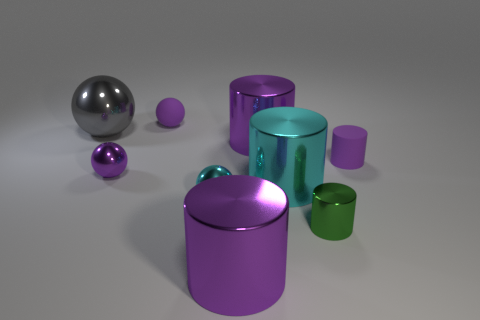Subtract all red balls. How many purple cylinders are left? 3 Subtract 1 spheres. How many spheres are left? 3 Subtract all gray cylinders. Subtract all green blocks. How many cylinders are left? 5 Add 1 matte objects. How many objects exist? 10 Subtract all cylinders. How many objects are left? 4 Add 1 metal balls. How many metal balls are left? 4 Add 2 tiny purple shiny balls. How many tiny purple shiny balls exist? 3 Subtract 0 green spheres. How many objects are left? 9 Subtract all purple metallic cylinders. Subtract all purple matte things. How many objects are left? 5 